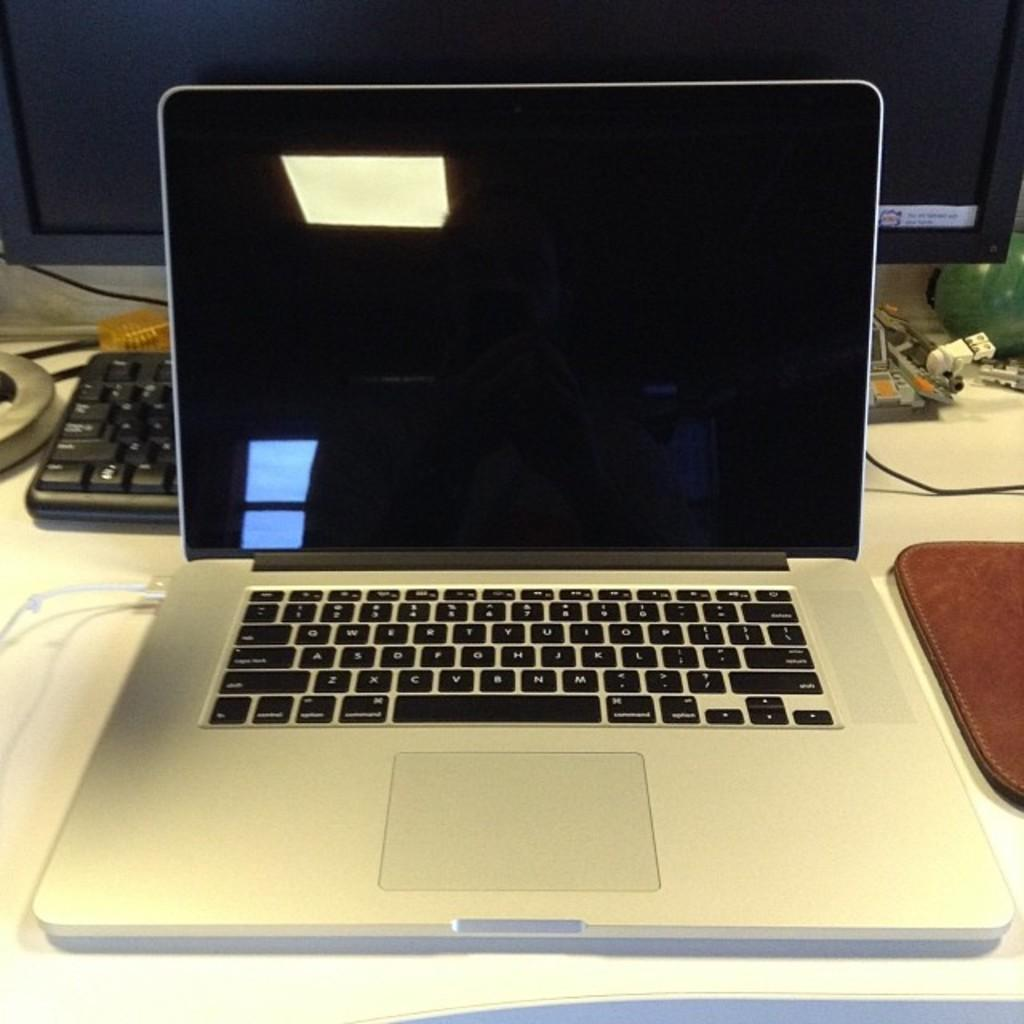<image>
Relay a brief, clear account of the picture shown. An open lap top computer sitting on a desk that is not turned on with the keyboard showing some of the letters shown are A, B, C and E. 